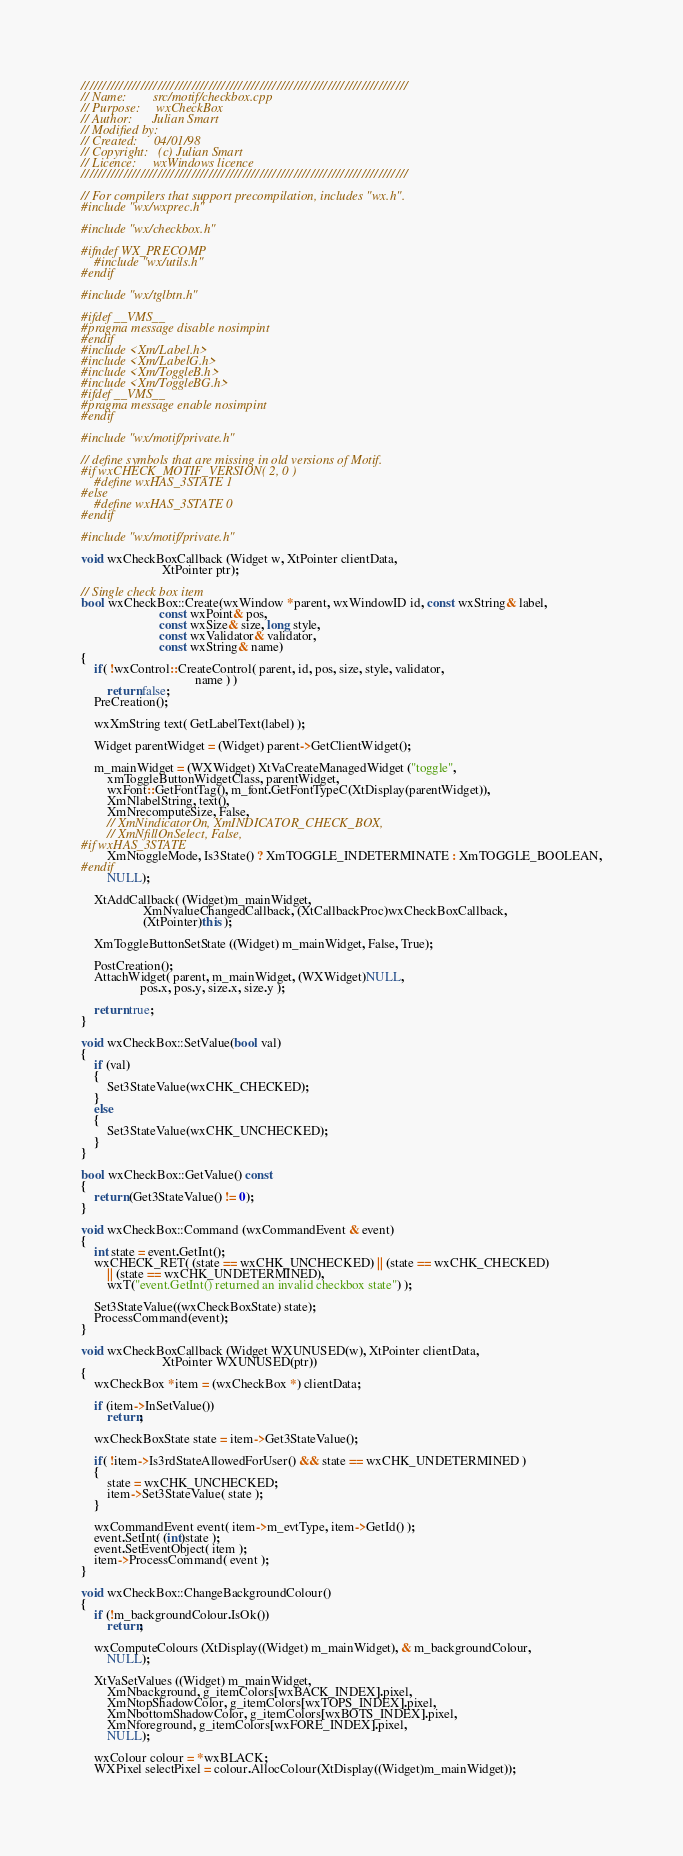Convert code to text. <code><loc_0><loc_0><loc_500><loc_500><_C++_>/////////////////////////////////////////////////////////////////////////////
// Name:        src/motif/checkbox.cpp
// Purpose:     wxCheckBox
// Author:      Julian Smart
// Modified by:
// Created:     04/01/98
// Copyright:   (c) Julian Smart
// Licence:     wxWindows licence
/////////////////////////////////////////////////////////////////////////////

// For compilers that support precompilation, includes "wx.h".
#include "wx/wxprec.h"

#include "wx/checkbox.h"

#ifndef WX_PRECOMP
    #include "wx/utils.h"
#endif

#include "wx/tglbtn.h"

#ifdef __VMS__
#pragma message disable nosimpint
#endif
#include <Xm/Label.h>
#include <Xm/LabelG.h>
#include <Xm/ToggleB.h>
#include <Xm/ToggleBG.h>
#ifdef __VMS__
#pragma message enable nosimpint
#endif

#include "wx/motif/private.h"

// define symbols that are missing in old versions of Motif.
#if wxCHECK_MOTIF_VERSION( 2, 0 )
    #define wxHAS_3STATE 1
#else
    #define wxHAS_3STATE 0
#endif

#include "wx/motif/private.h"

void wxCheckBoxCallback (Widget w, XtPointer clientData,
                         XtPointer ptr);

// Single check box item
bool wxCheckBox::Create(wxWindow *parent, wxWindowID id, const wxString& label,
                        const wxPoint& pos,
                        const wxSize& size, long style,
                        const wxValidator& validator,
                        const wxString& name)
{
    if( !wxControl::CreateControl( parent, id, pos, size, style, validator,
                                   name ) )
        return false;
    PreCreation();

    wxXmString text( GetLabelText(label) );

    Widget parentWidget = (Widget) parent->GetClientWidget();

    m_mainWidget = (WXWidget) XtVaCreateManagedWidget ("toggle",
        xmToggleButtonWidgetClass, parentWidget,
        wxFont::GetFontTag(), m_font.GetFontTypeC(XtDisplay(parentWidget)),
        XmNlabelString, text(),
        XmNrecomputeSize, False,
        // XmNindicatorOn, XmINDICATOR_CHECK_BOX,
        // XmNfillOnSelect, False,
#if wxHAS_3STATE
        XmNtoggleMode, Is3State() ? XmTOGGLE_INDETERMINATE : XmTOGGLE_BOOLEAN,
#endif
        NULL);

    XtAddCallback( (Widget)m_mainWidget,
                   XmNvalueChangedCallback, (XtCallbackProc)wxCheckBoxCallback,
                   (XtPointer)this );

    XmToggleButtonSetState ((Widget) m_mainWidget, False, True);

    PostCreation();
    AttachWidget( parent, m_mainWidget, (WXWidget)NULL,
                  pos.x, pos.y, size.x, size.y );

    return true;
}

void wxCheckBox::SetValue(bool val)
{
    if (val)
    {
        Set3StateValue(wxCHK_CHECKED);
    }
    else
    {
        Set3StateValue(wxCHK_UNCHECKED);
    }
}

bool wxCheckBox::GetValue() const
{
    return (Get3StateValue() != 0);
}

void wxCheckBox::Command (wxCommandEvent & event)
{
    int state = event.GetInt();
    wxCHECK_RET( (state == wxCHK_UNCHECKED) || (state == wxCHK_CHECKED)
        || (state == wxCHK_UNDETERMINED),
        wxT("event.GetInt() returned an invalid checkbox state") );

    Set3StateValue((wxCheckBoxState) state);
    ProcessCommand(event);
}

void wxCheckBoxCallback (Widget WXUNUSED(w), XtPointer clientData,
                         XtPointer WXUNUSED(ptr))
{
    wxCheckBox *item = (wxCheckBox *) clientData;

    if (item->InSetValue())
        return;

    wxCheckBoxState state = item->Get3StateValue();

    if( !item->Is3rdStateAllowedForUser() && state == wxCHK_UNDETERMINED )
    {
        state = wxCHK_UNCHECKED;
        item->Set3StateValue( state );
    }

    wxCommandEvent event( item->m_evtType, item->GetId() );
    event.SetInt( (int)state );
    event.SetEventObject( item );
    item->ProcessCommand( event );
}

void wxCheckBox::ChangeBackgroundColour()
{
    if (!m_backgroundColour.IsOk())
        return;

    wxComputeColours (XtDisplay((Widget) m_mainWidget), & m_backgroundColour,
        NULL);

    XtVaSetValues ((Widget) m_mainWidget,
        XmNbackground, g_itemColors[wxBACK_INDEX].pixel,
        XmNtopShadowColor, g_itemColors[wxTOPS_INDEX].pixel,
        XmNbottomShadowColor, g_itemColors[wxBOTS_INDEX].pixel,
        XmNforeground, g_itemColors[wxFORE_INDEX].pixel,
        NULL);

    wxColour colour = *wxBLACK;
    WXPixel selectPixel = colour.AllocColour(XtDisplay((Widget)m_mainWidget));
</code> 